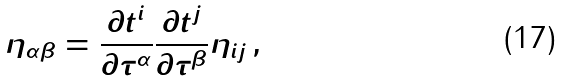Convert formula to latex. <formula><loc_0><loc_0><loc_500><loc_500>\eta _ { \alpha \beta } = \frac { \partial t ^ { i } } { \partial \tau ^ { \alpha } } \frac { \partial t ^ { j } } { \partial \tau ^ { \beta } } \eta _ { i j } \, ,</formula> 